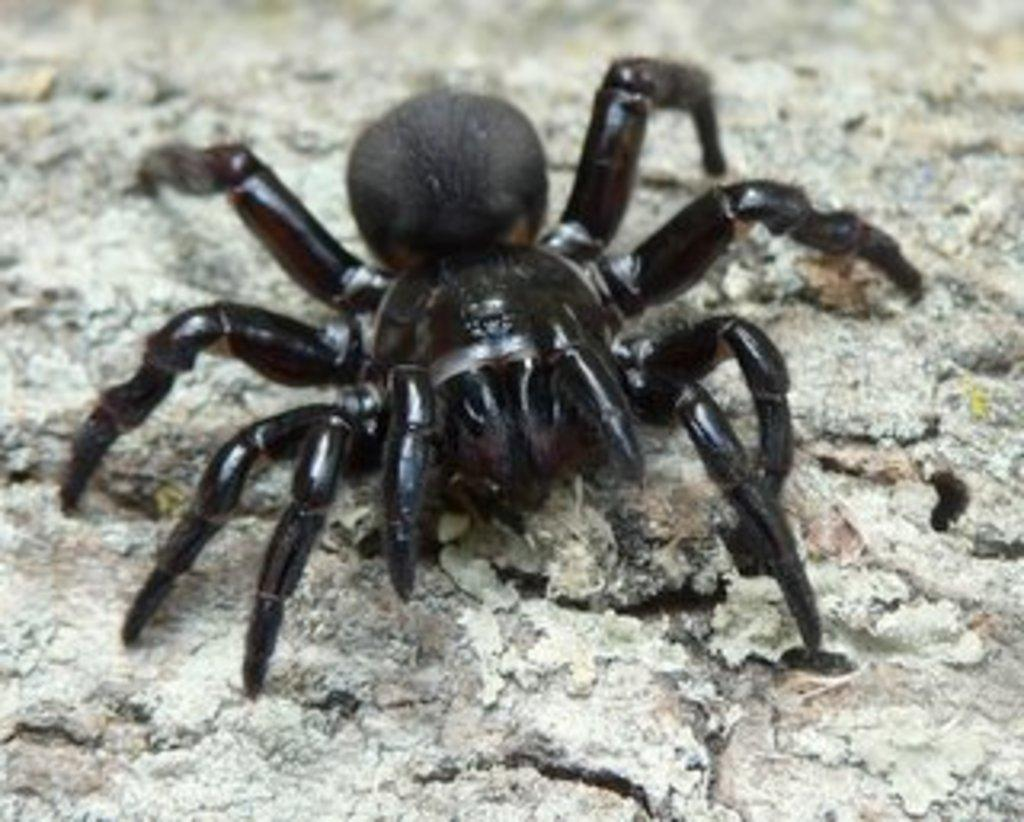What is the main subject of the image? The main subject of the image is a spider. Where is the spider located in the image? The spider is on a rock surface. How many bikes are parked next to the spider in the image? There are no bikes present in the image; it only features a spider on a rock surface. What is the spider's interest in the process of photosynthesis? There is no information about the spider's interest in the process of photosynthesis, as the image only shows the spider on a rock surface. 